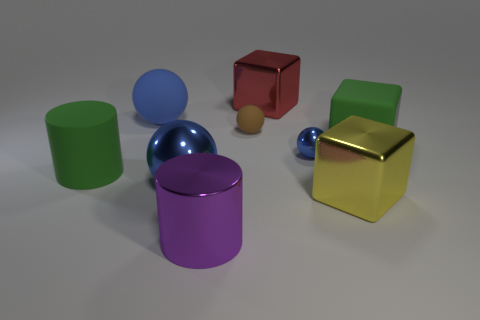There is a cylinder that is behind the large metal cylinder; does it have the same color as the big rubber object right of the large purple shiny object?
Your response must be concise. Yes. Is there a small green sphere made of the same material as the tiny brown object?
Give a very brief answer. No. Are there more large red metal things that are behind the green cylinder than big yellow metallic objects behind the large yellow block?
Make the answer very short. Yes. What size is the rubber cylinder?
Make the answer very short. Large. The large metallic thing that is to the left of the purple object has what shape?
Offer a terse response. Sphere. Does the large yellow thing have the same shape as the brown object?
Provide a succinct answer. No. Is the number of big red shiny objects that are on the left side of the tiny rubber thing the same as the number of small blue things?
Provide a succinct answer. No. What is the shape of the small rubber object?
Your answer should be very brief. Sphere. Are there any other things of the same color as the shiny cylinder?
Give a very brief answer. No. Does the blue sphere to the right of the big purple metallic cylinder have the same size as the purple cylinder in front of the red metal object?
Make the answer very short. No. 